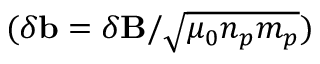<formula> <loc_0><loc_0><loc_500><loc_500>( \delta b = \delta B / \sqrt { \mu _ { 0 } n _ { p } m _ { p } } )</formula> 